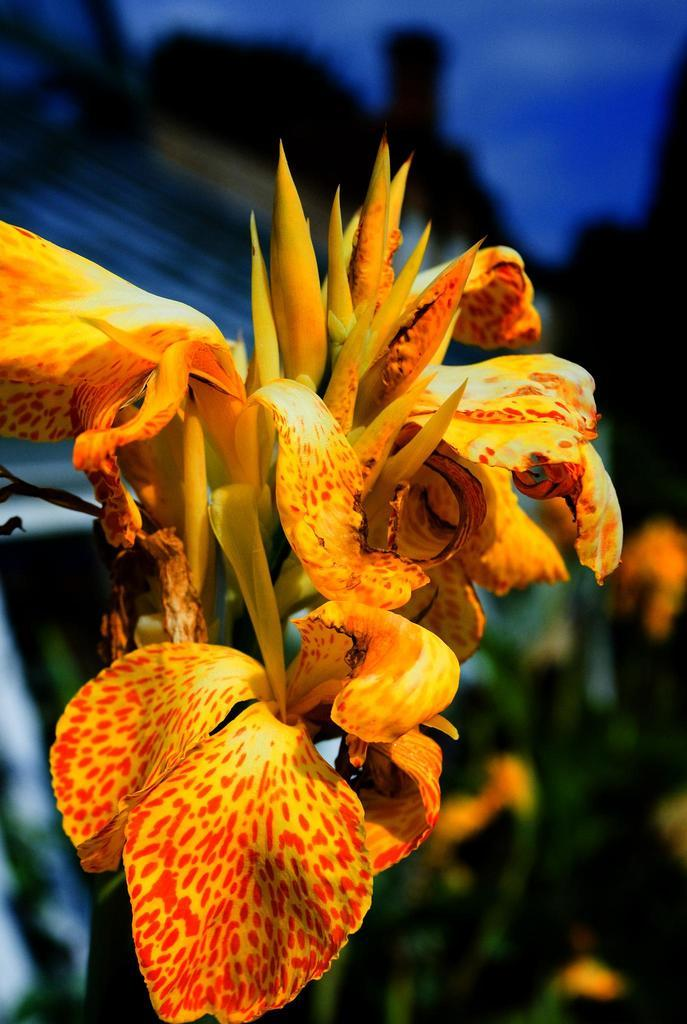What is the main subject of the image? There is a flower in the image. Can you describe the colors of the flower? The flower has yellow and orange colors. What else can be seen in the background of the image? There are leaves and the sky visible in the background. What color are the leaves? The leaves are green. What color is the sky in the image? The sky has a blue color. What type of friction can be observed between the flower and the leaves in the image? There is no friction present between the flower and the leaves in the image, as they are not interacting with each other. How many dolls are visible in the image? There are no dolls present in the image; it features a flower, leaves, and the sky. 